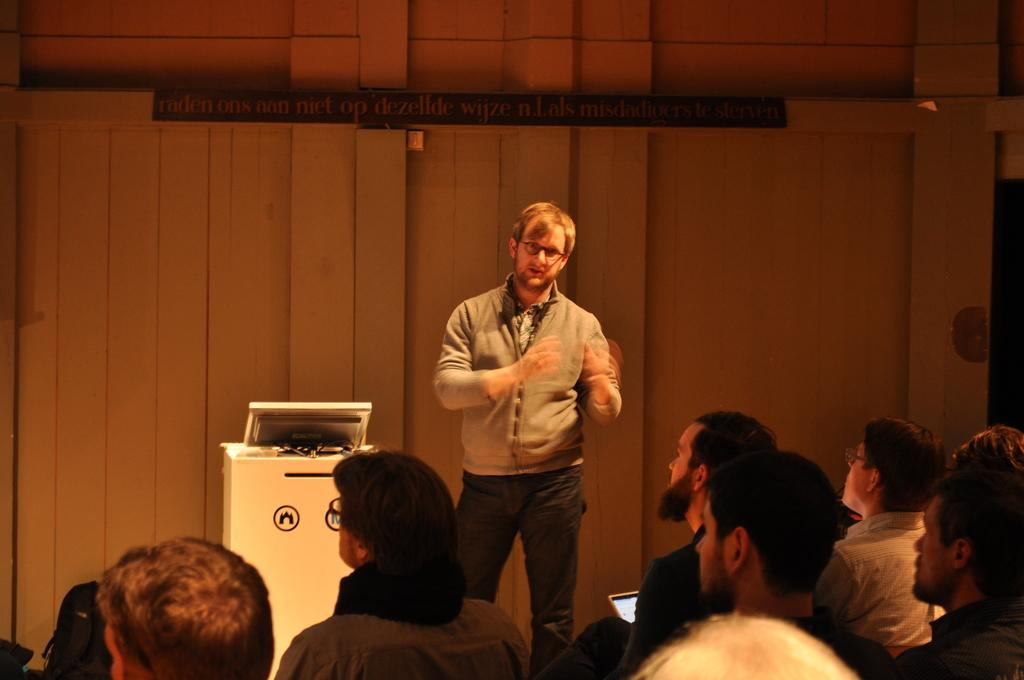What are the people in the image doing? The people in the image are sitting. What is the man in the image doing? The man in the image is standing and appears to be speaking. What can be seen on the table in the image? There is a monitor on a table in the image. What type of wall is visible in the background of the image? There is a wooden wall in the background of the image. What type of store can be seen in the background of the image? There is no store visible in the background of the image; it features a wooden wall. What type of chain is being used by the people in the image? There is no chain present in the image; the people are sitting and standing without any visible restraints. 